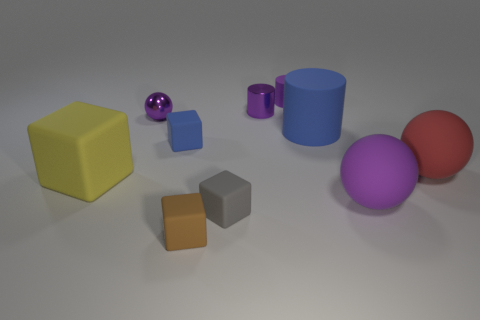How big is the purple sphere that is in front of the small blue cube?
Ensure brevity in your answer.  Large. There is a purple sphere to the right of the purple sphere behind the big red matte thing; how many large yellow blocks are in front of it?
Your answer should be very brief. 0. Are there any tiny brown cubes behind the big cube?
Offer a terse response. No. How many other things are there of the same size as the red ball?
Give a very brief answer. 3. There is a ball that is behind the yellow thing and right of the gray matte object; what is its material?
Your response must be concise. Rubber. There is a matte object that is left of the tiny sphere; is its shape the same as the purple thing in front of the large blue object?
Make the answer very short. No. Is there any other thing that has the same material as the brown cube?
Provide a short and direct response. Yes. What is the shape of the purple metallic object to the left of the cube that is behind the big rubber ball behind the big purple matte ball?
Ensure brevity in your answer.  Sphere. What number of other things are the same shape as the big purple thing?
Offer a very short reply. 2. The metal cylinder that is the same size as the metal ball is what color?
Your answer should be compact. Purple. 